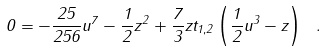Convert formula to latex. <formula><loc_0><loc_0><loc_500><loc_500>0 = - \frac { 2 5 } { 2 5 6 } u ^ { 7 } - \frac { 1 } { 2 } z ^ { 2 } + \frac { 7 } { 3 } z t _ { 1 , 2 } \left ( \frac { 1 } { 2 } u ^ { 3 } - z \right ) \ .</formula> 